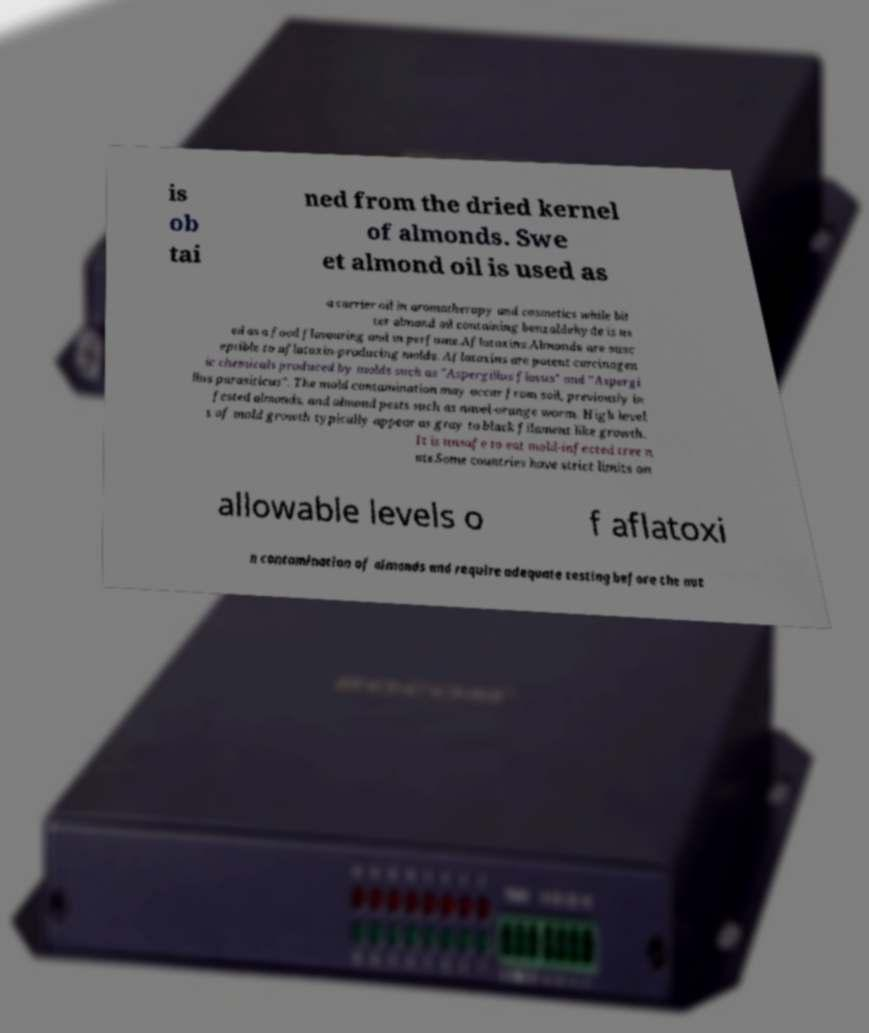For documentation purposes, I need the text within this image transcribed. Could you provide that? is ob tai ned from the dried kernel of almonds. Swe et almond oil is used as a carrier oil in aromatherapy and cosmetics while bit ter almond oil containing benzaldehyde is us ed as a food flavouring and in perfume.Aflatoxins.Almonds are susc eptible to aflatoxin-producing molds. Aflatoxins are potent carcinogen ic chemicals produced by molds such as "Aspergillus flavus" and "Aspergi llus parasiticus". The mold contamination may occur from soil, previously in fested almonds, and almond pests such as navel-orange worm. High level s of mold growth typically appear as gray to black filament like growth. It is unsafe to eat mold-infected tree n uts.Some countries have strict limits on allowable levels o f aflatoxi n contamination of almonds and require adequate testing before the nut 